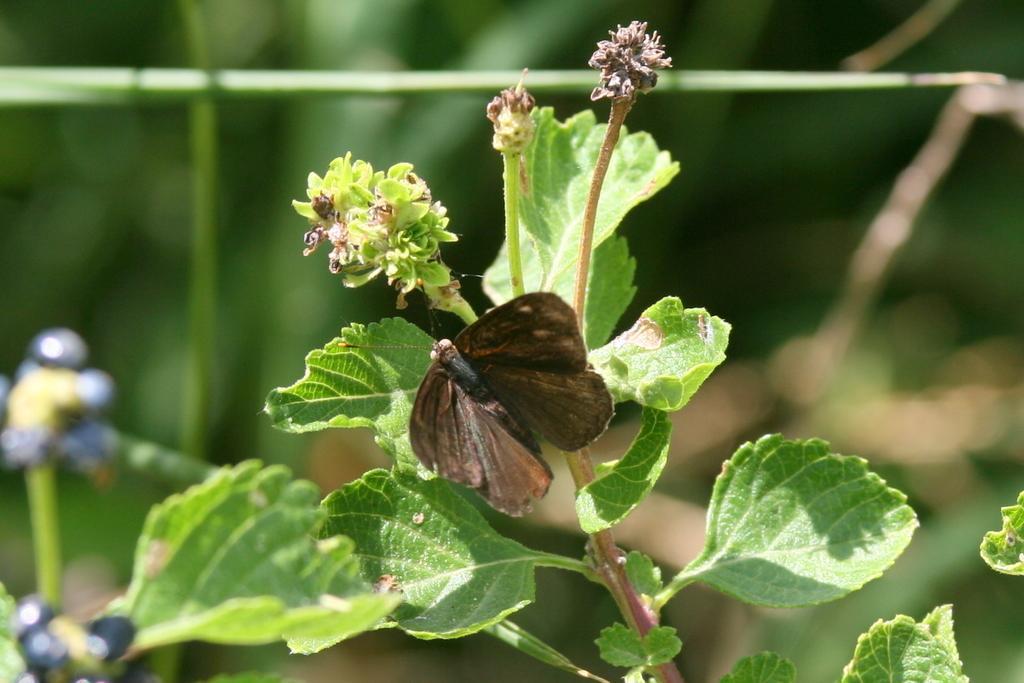Describe this image in one or two sentences. In the center of the image we can see a butterfly is present on the plant and also we can see flowers, bud are there. In the background the image is blur. 